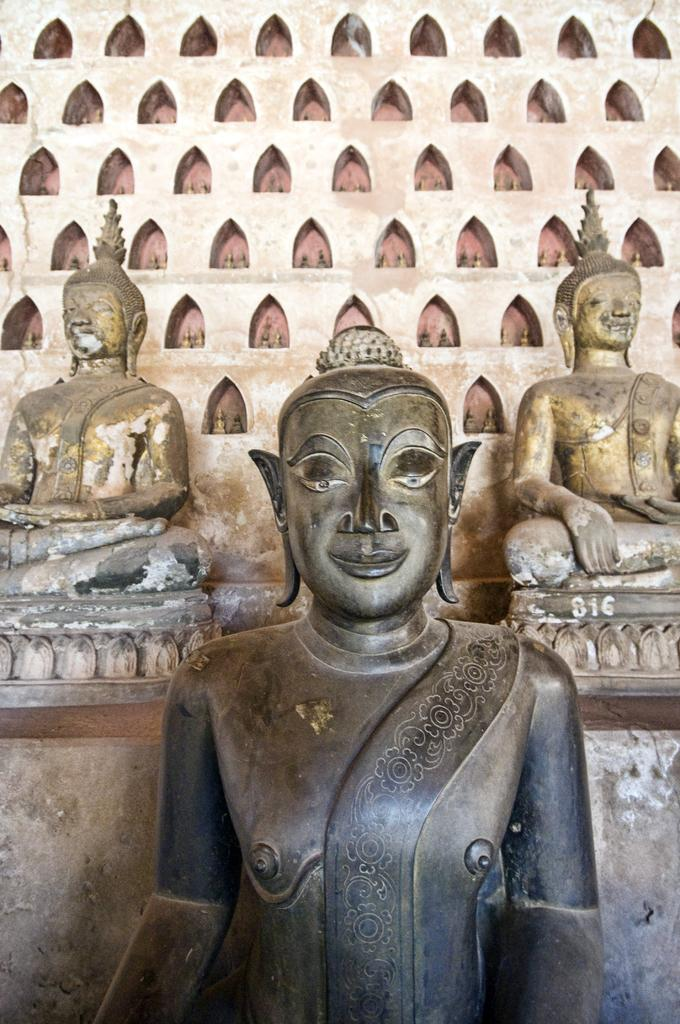What is the main subject of the image? There is a Buddha sculpture in the image. Are there any other similar subjects in the image? Yes, there are two additional Buddha sculptures behind the first one. What can be seen behind the sculptures? There is a wall visible behind the sculptures. Who won the writing competition depicted in the image? There is no writing competition or any indication of a competition in the image; it features Buddha sculptures and a wall. 